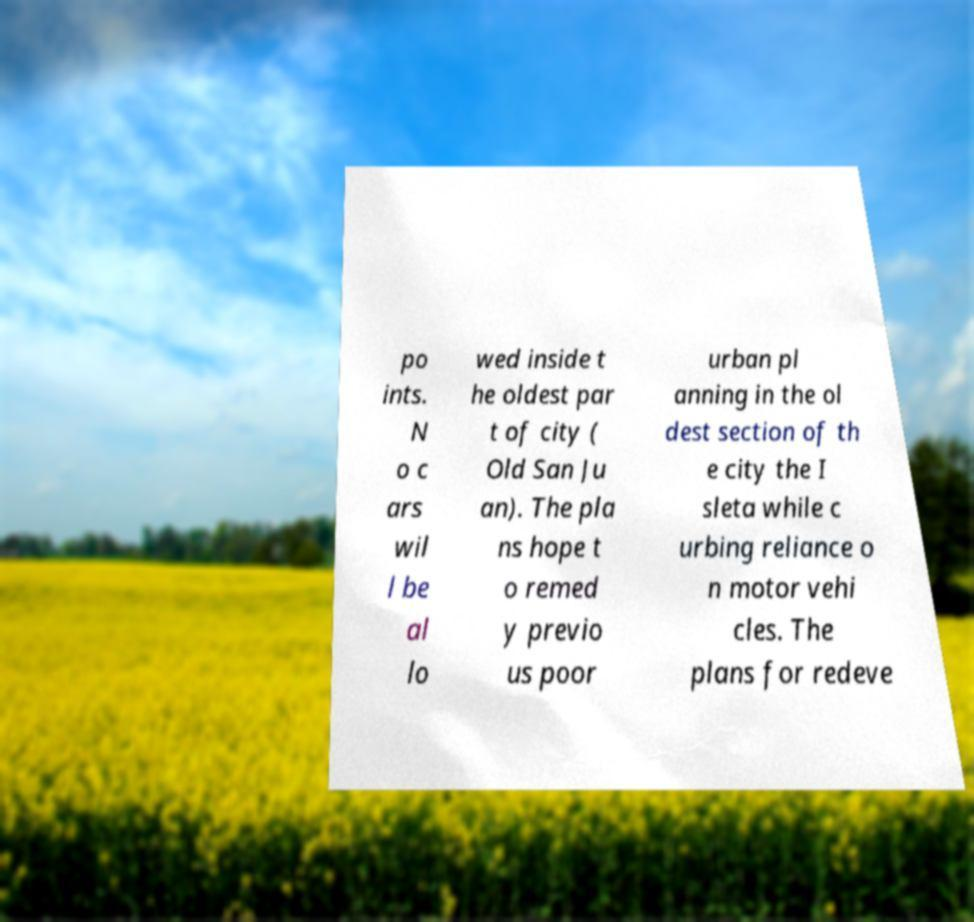Could you extract and type out the text from this image? po ints. N o c ars wil l be al lo wed inside t he oldest par t of city ( Old San Ju an). The pla ns hope t o remed y previo us poor urban pl anning in the ol dest section of th e city the I sleta while c urbing reliance o n motor vehi cles. The plans for redeve 